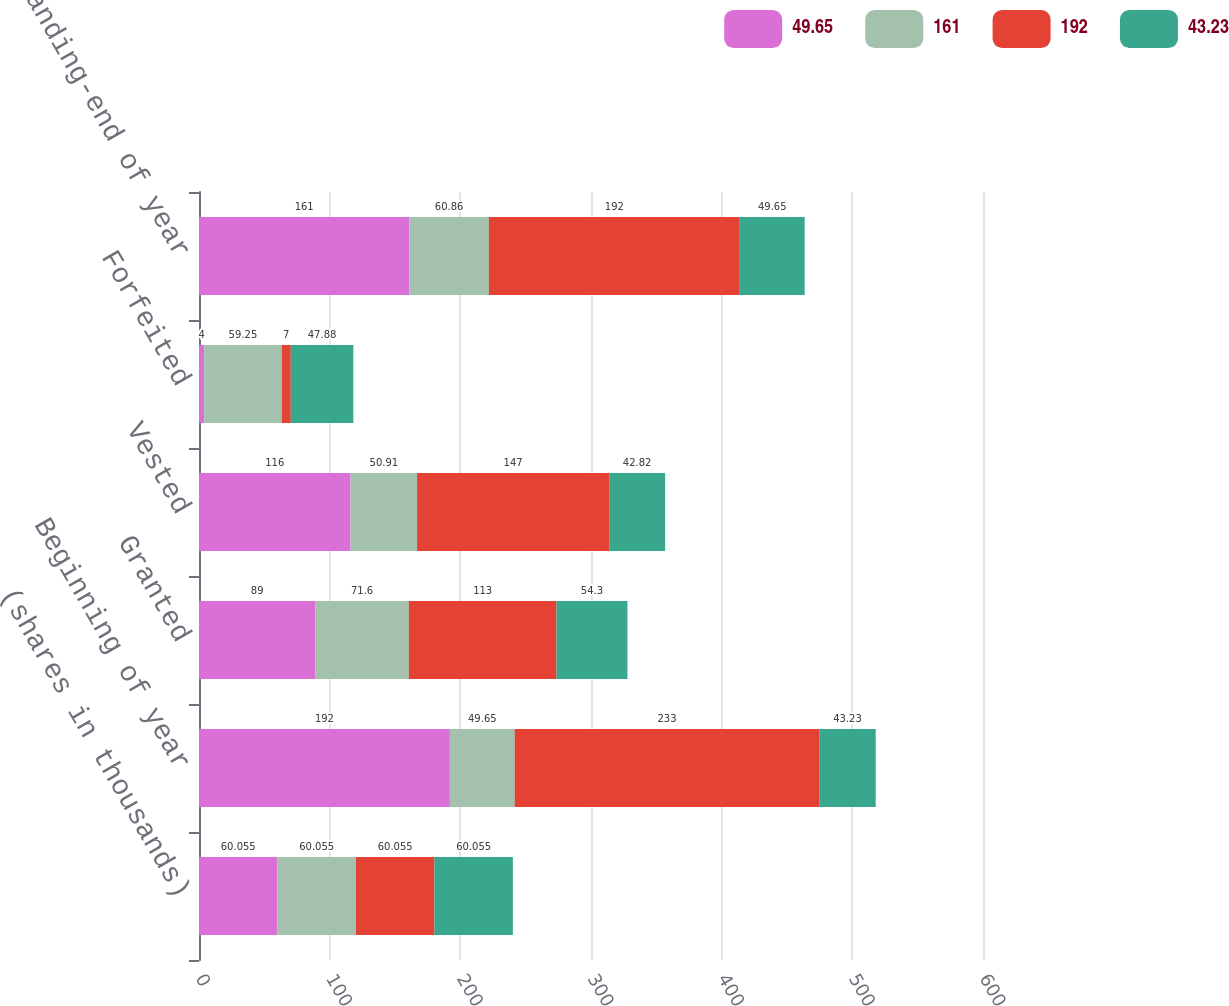Convert chart. <chart><loc_0><loc_0><loc_500><loc_500><stacked_bar_chart><ecel><fcel>(shares in thousands)<fcel>Beginning of year<fcel>Granted<fcel>Vested<fcel>Forfeited<fcel>Outstanding-end of year<nl><fcel>49.65<fcel>60.055<fcel>192<fcel>89<fcel>116<fcel>4<fcel>161<nl><fcel>161<fcel>60.055<fcel>49.65<fcel>71.6<fcel>50.91<fcel>59.25<fcel>60.86<nl><fcel>192<fcel>60.055<fcel>233<fcel>113<fcel>147<fcel>7<fcel>192<nl><fcel>43.23<fcel>60.055<fcel>43.23<fcel>54.3<fcel>42.82<fcel>47.88<fcel>49.65<nl></chart> 